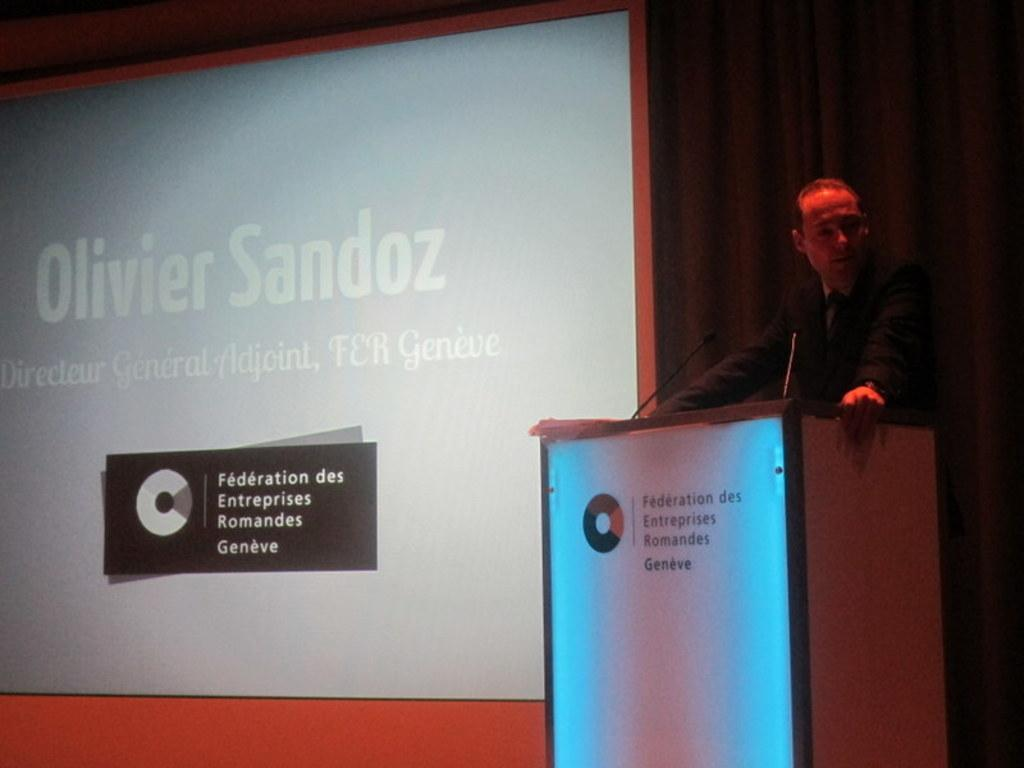What is the person in the image doing? The person is standing on a dais and delivering a speech. What objects are in front of the person? There are two microphones in front of the person. What is located beside the person? There is a giant screen beside the person. What type of crate is being used for the discussion in the image? There is no crate present in the image, nor is there any discussion taking place. 